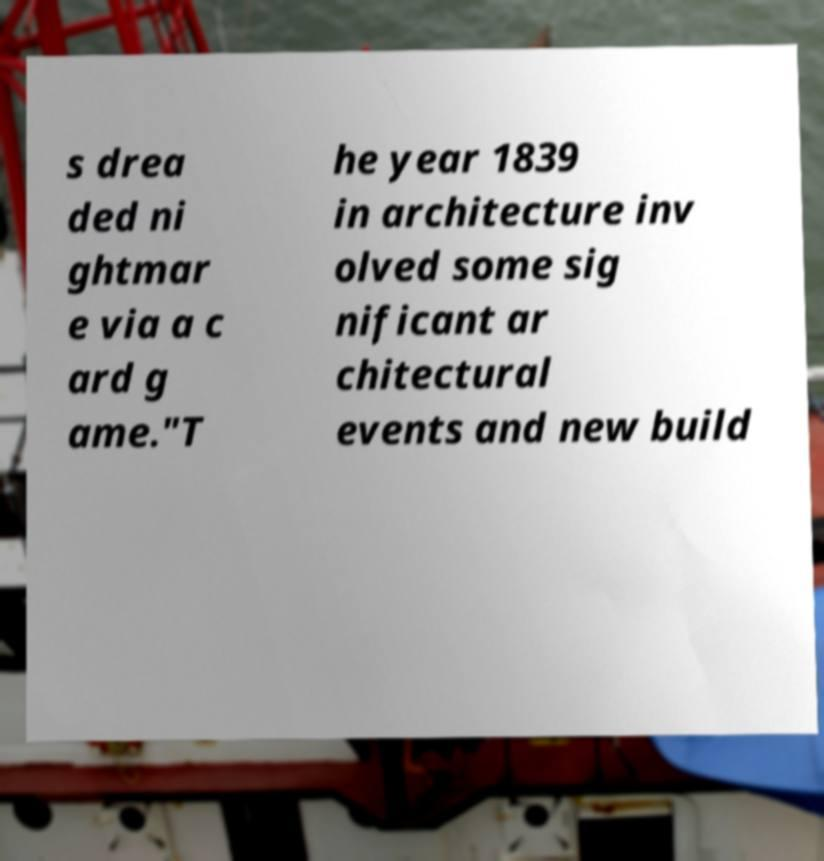There's text embedded in this image that I need extracted. Can you transcribe it verbatim? s drea ded ni ghtmar e via a c ard g ame."T he year 1839 in architecture inv olved some sig nificant ar chitectural events and new build 